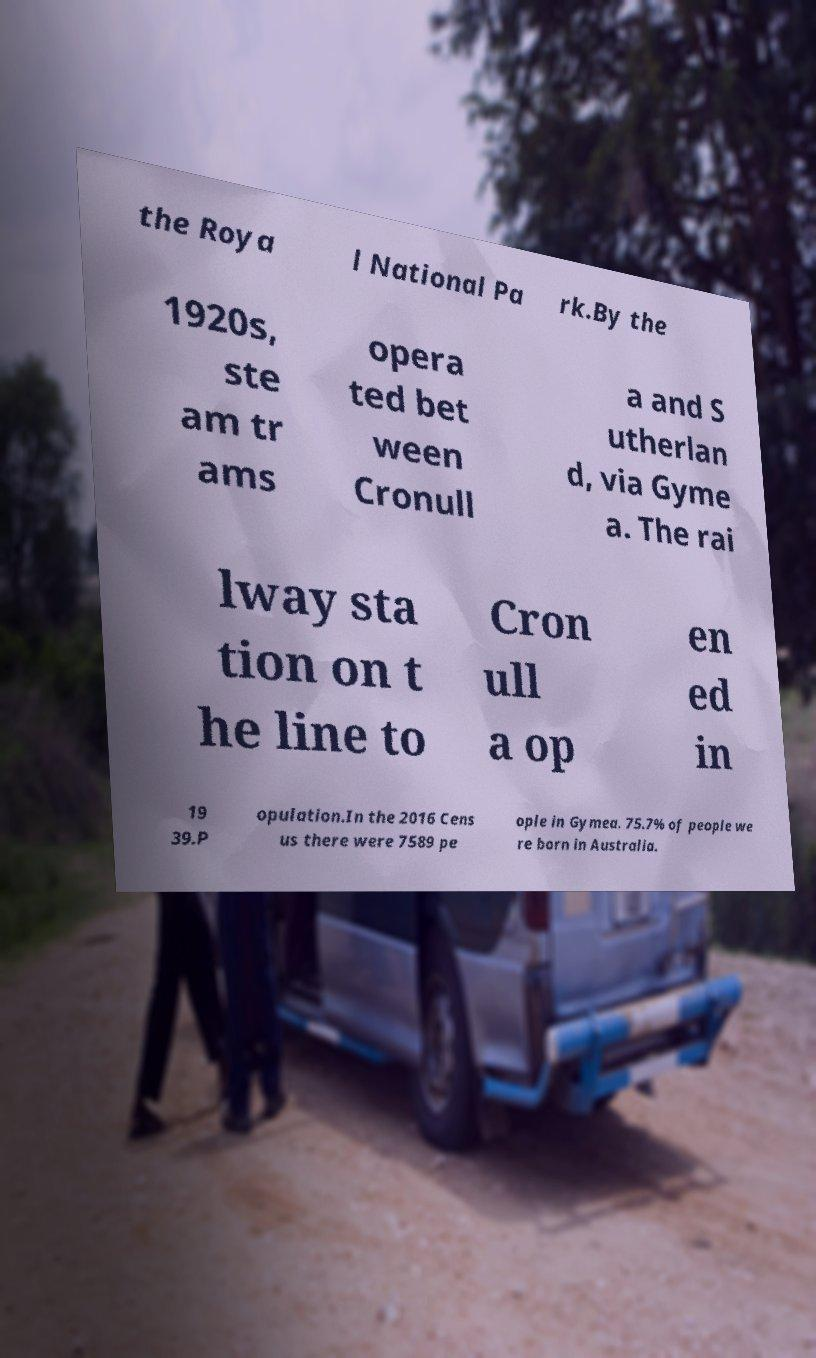Could you extract and type out the text from this image? the Roya l National Pa rk.By the 1920s, ste am tr ams opera ted bet ween Cronull a and S utherlan d, via Gyme a. The rai lway sta tion on t he line to Cron ull a op en ed in 19 39.P opulation.In the 2016 Cens us there were 7589 pe ople in Gymea. 75.7% of people we re born in Australia. 